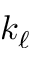<formula> <loc_0><loc_0><loc_500><loc_500>k _ { \ell }</formula> 